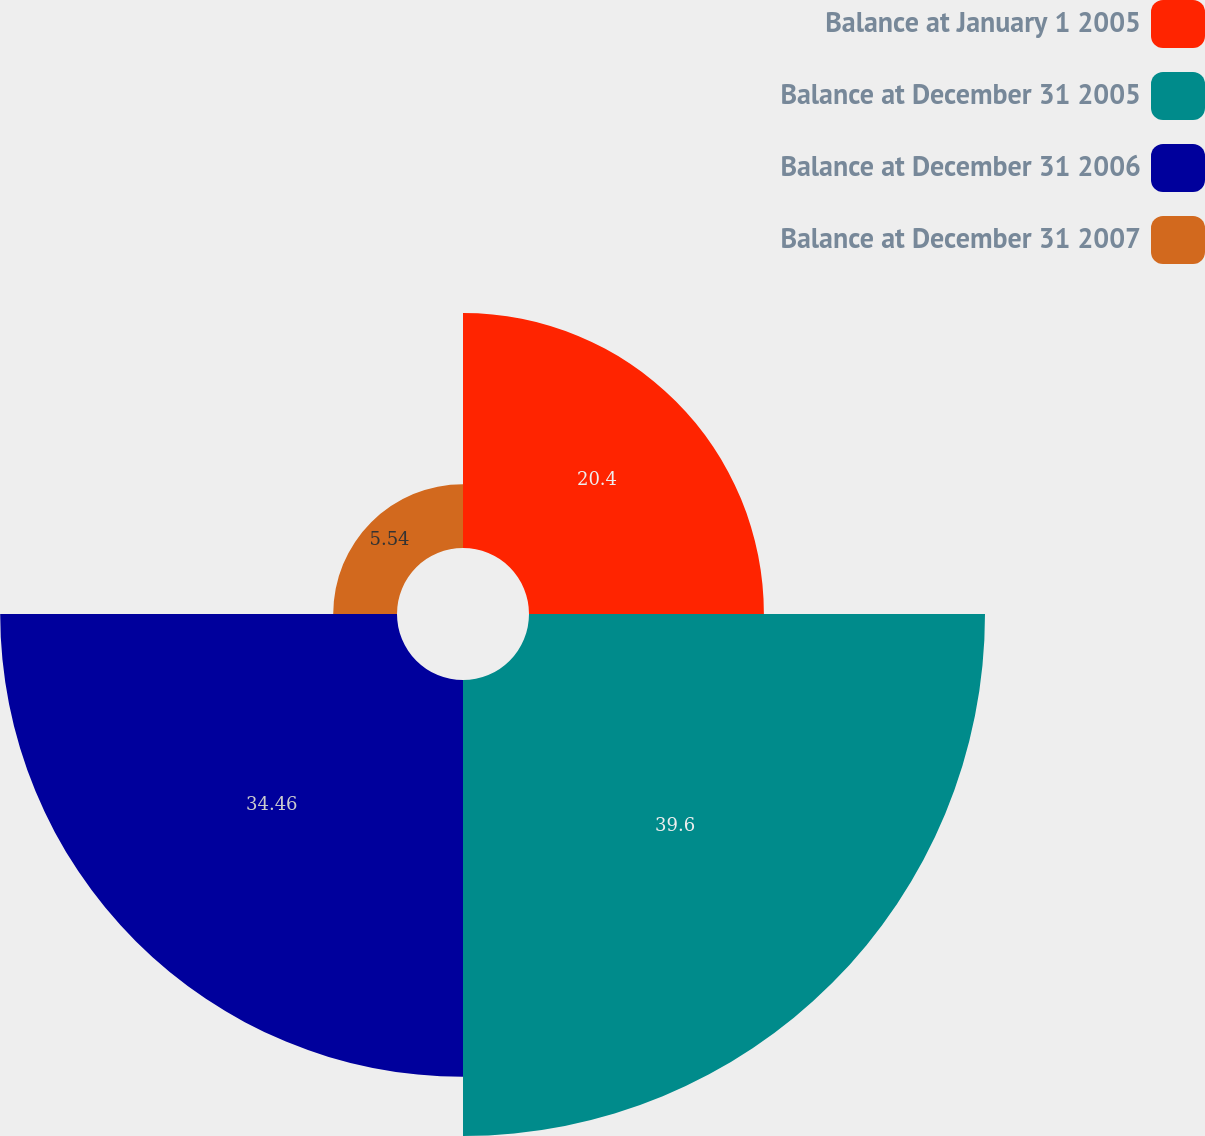Convert chart to OTSL. <chart><loc_0><loc_0><loc_500><loc_500><pie_chart><fcel>Balance at January 1 2005<fcel>Balance at December 31 2005<fcel>Balance at December 31 2006<fcel>Balance at December 31 2007<nl><fcel>20.4%<fcel>39.6%<fcel>34.46%<fcel>5.54%<nl></chart> 